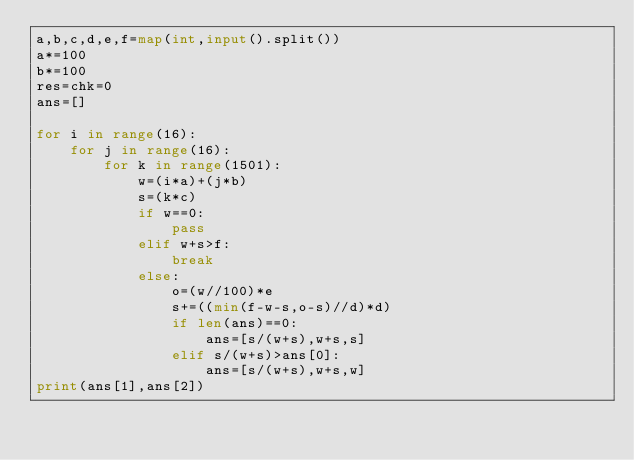<code> <loc_0><loc_0><loc_500><loc_500><_Python_>a,b,c,d,e,f=map(int,input().split())
a*=100
b*=100
res=chk=0
ans=[]

for i in range(16):
    for j in range(16):
        for k in range(1501):
            w=(i*a)+(j*b)
            s=(k*c)
            if w==0:
                pass
            elif w+s>f:
                break
            else:
                o=(w//100)*e
                s+=((min(f-w-s,o-s)//d)*d)
                if len(ans)==0:
                    ans=[s/(w+s),w+s,s]
                elif s/(w+s)>ans[0]:
                    ans=[s/(w+s),w+s,w]
print(ans[1],ans[2])
</code> 